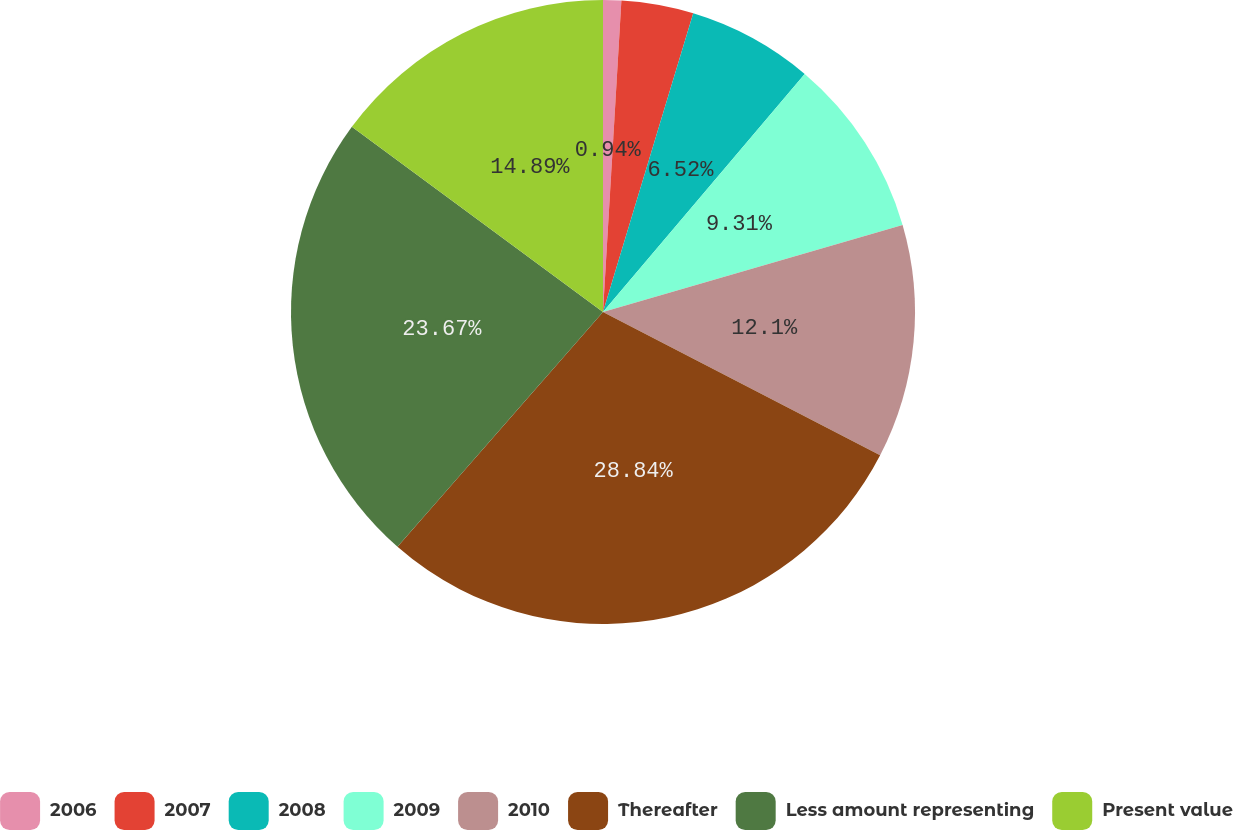Convert chart to OTSL. <chart><loc_0><loc_0><loc_500><loc_500><pie_chart><fcel>2006<fcel>2007<fcel>2008<fcel>2009<fcel>2010<fcel>Thereafter<fcel>Less amount representing<fcel>Present value<nl><fcel>0.94%<fcel>3.73%<fcel>6.52%<fcel>9.31%<fcel>12.1%<fcel>28.85%<fcel>23.67%<fcel>14.89%<nl></chart> 